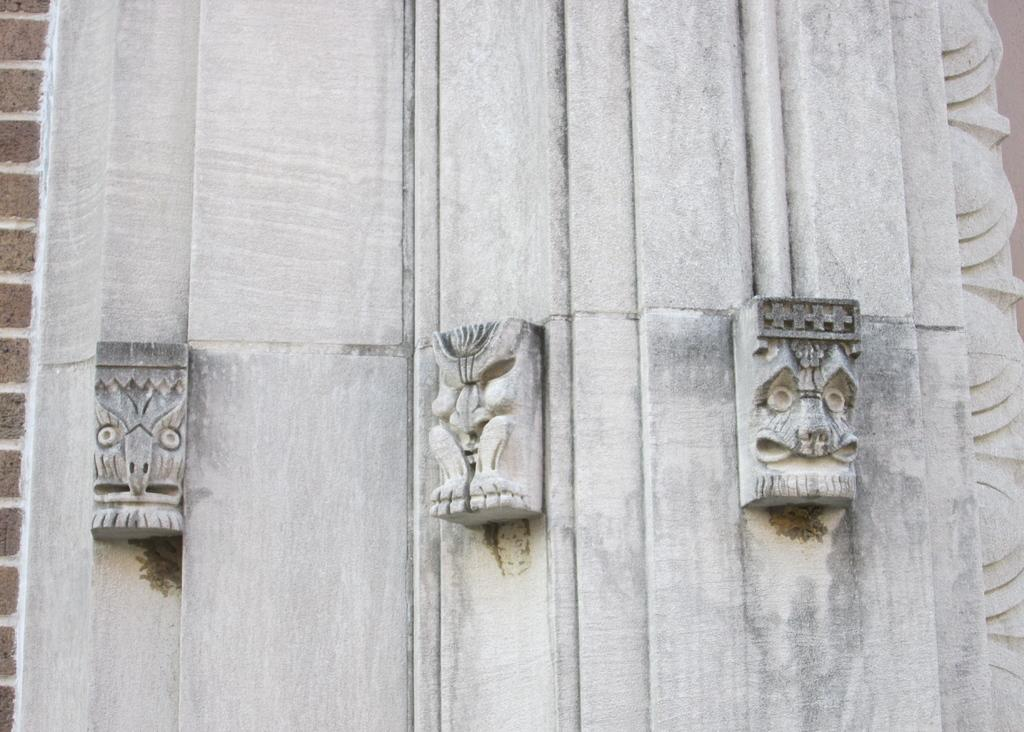What type of wall is visible on the right side of the image? There is a white wall with stone carved statues on the right side of the image. What is the color and material of the wall on the left side of the image? The wall on the left side of the image is made up of brown colored bricks. How many eyes can be seen on the paper in the image? There is no paper present in the image, and therefore no eyes can be seen on it. 